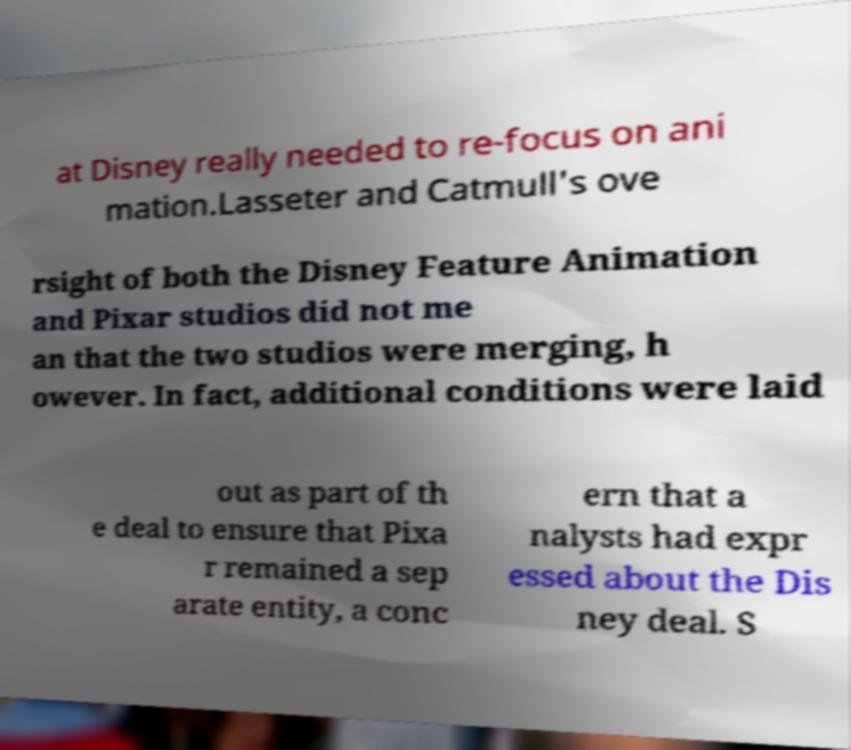Could you extract and type out the text from this image? at Disney really needed to re-focus on ani mation.Lasseter and Catmull's ove rsight of both the Disney Feature Animation and Pixar studios did not me an that the two studios were merging, h owever. In fact, additional conditions were laid out as part of th e deal to ensure that Pixa r remained a sep arate entity, a conc ern that a nalysts had expr essed about the Dis ney deal. S 